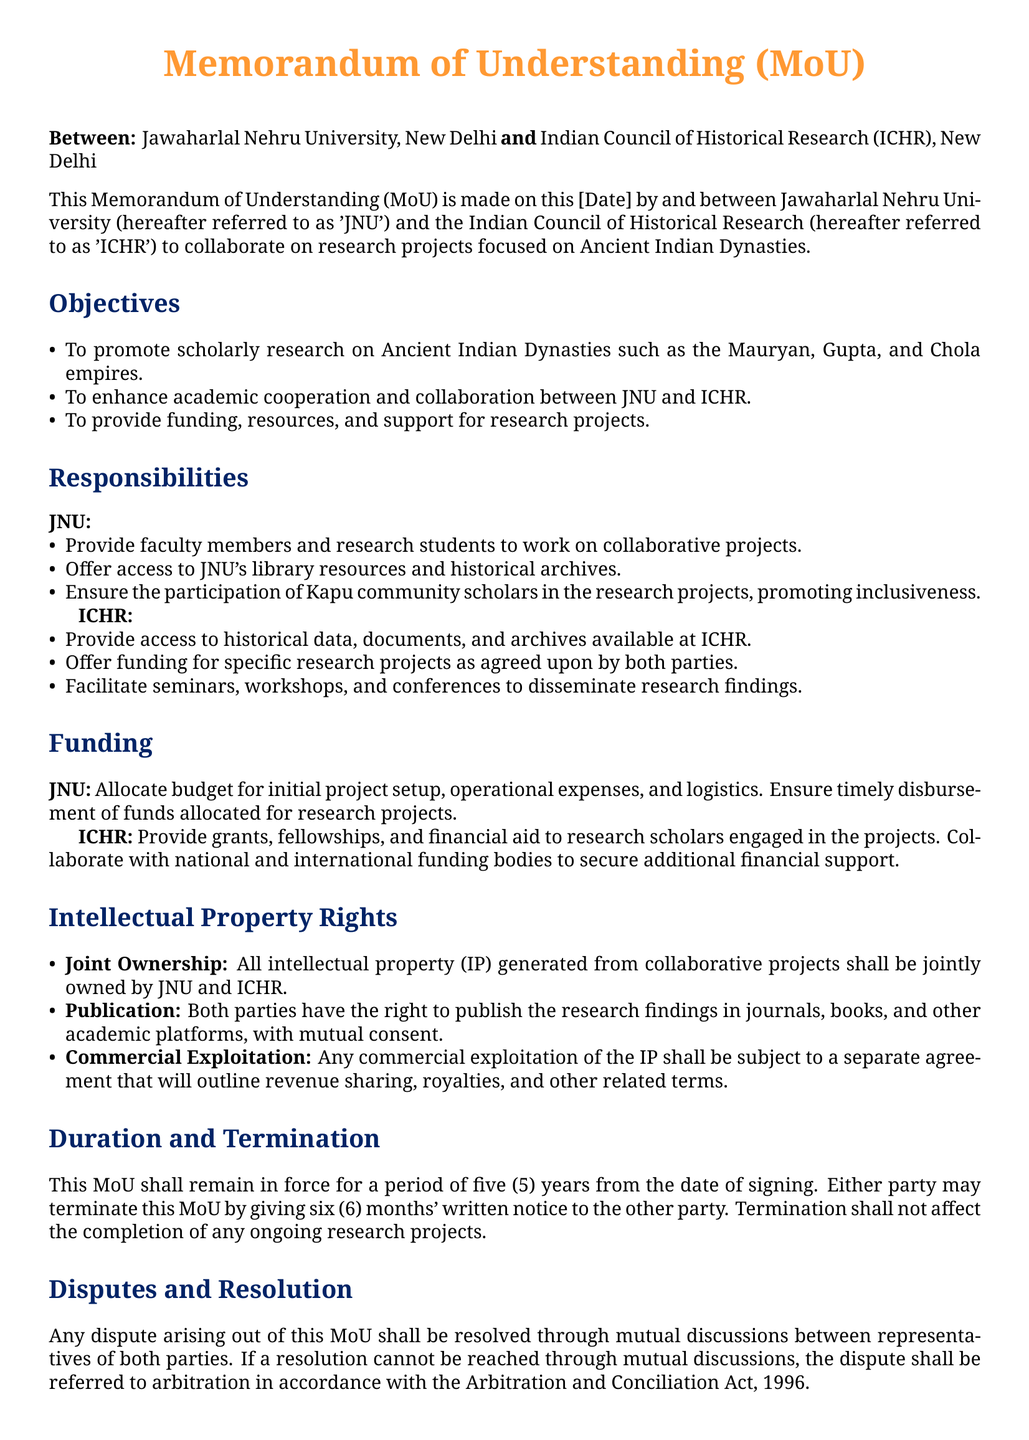what are the names of the parties involved in the MoU? The document specifies the parties involved in the MoU as Jawaharlal Nehru University and Indian Council of Historical Research.
Answer: Jawaharlal Nehru University, Indian Council of Historical Research what is the duration of the MoU? The document states that the MoU shall remain in force for a period of five years from the date of signing.
Answer: five years who is responsible for providing access to historical data? The document highlights that the Indian Council of Historical Research is responsible for providing access to historical data, documents, and archives.
Answer: Indian Council of Historical Research how many months' notice is required for termination of the MoU? The document requires either party to give six months' written notice to the other party for termination.
Answer: six months what type of ownership is specified for intellectual property generated? The document states that all intellectual property generated from collaborative projects shall be jointly owned by both parties.
Answer: Joint Ownership how will disputes be resolved according to the MoU? The document specifies that any dispute arising out of the MoU shall be resolved through mutual discussions between representatives of both parties, and if unresolved, referred to arbitration.
Answer: mutual discussions what is the main objective of this collaboration? The document lists the promotion of scholarly research on Ancient Indian Dynasties as a key objective of the collaboration.
Answer: promote scholarly research on Ancient Indian Dynasties what type of financial support does ICHR provide? The document indicates that ICHR provides grants, fellowships, and financial aid to research scholars engaged in the projects.
Answer: grants, fellowships, and financial aid who are the signatories at the end of the document? The document mentions that the signatories include the Vice-Chancellor of JNU and the Chairperson of ICHR.
Answer: Vice-Chancellor, JNU; Chairperson, ICHR 